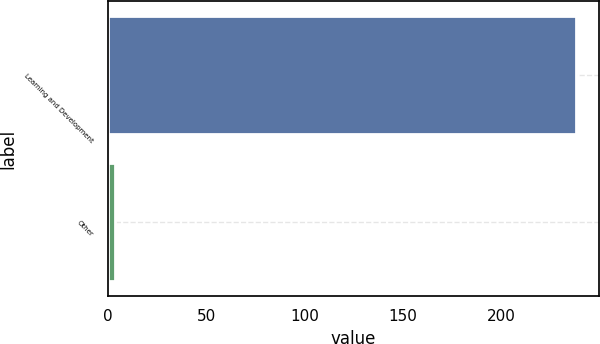Convert chart to OTSL. <chart><loc_0><loc_0><loc_500><loc_500><bar_chart><fcel>Learning and Development<fcel>Other<nl><fcel>237.9<fcel>3.8<nl></chart> 